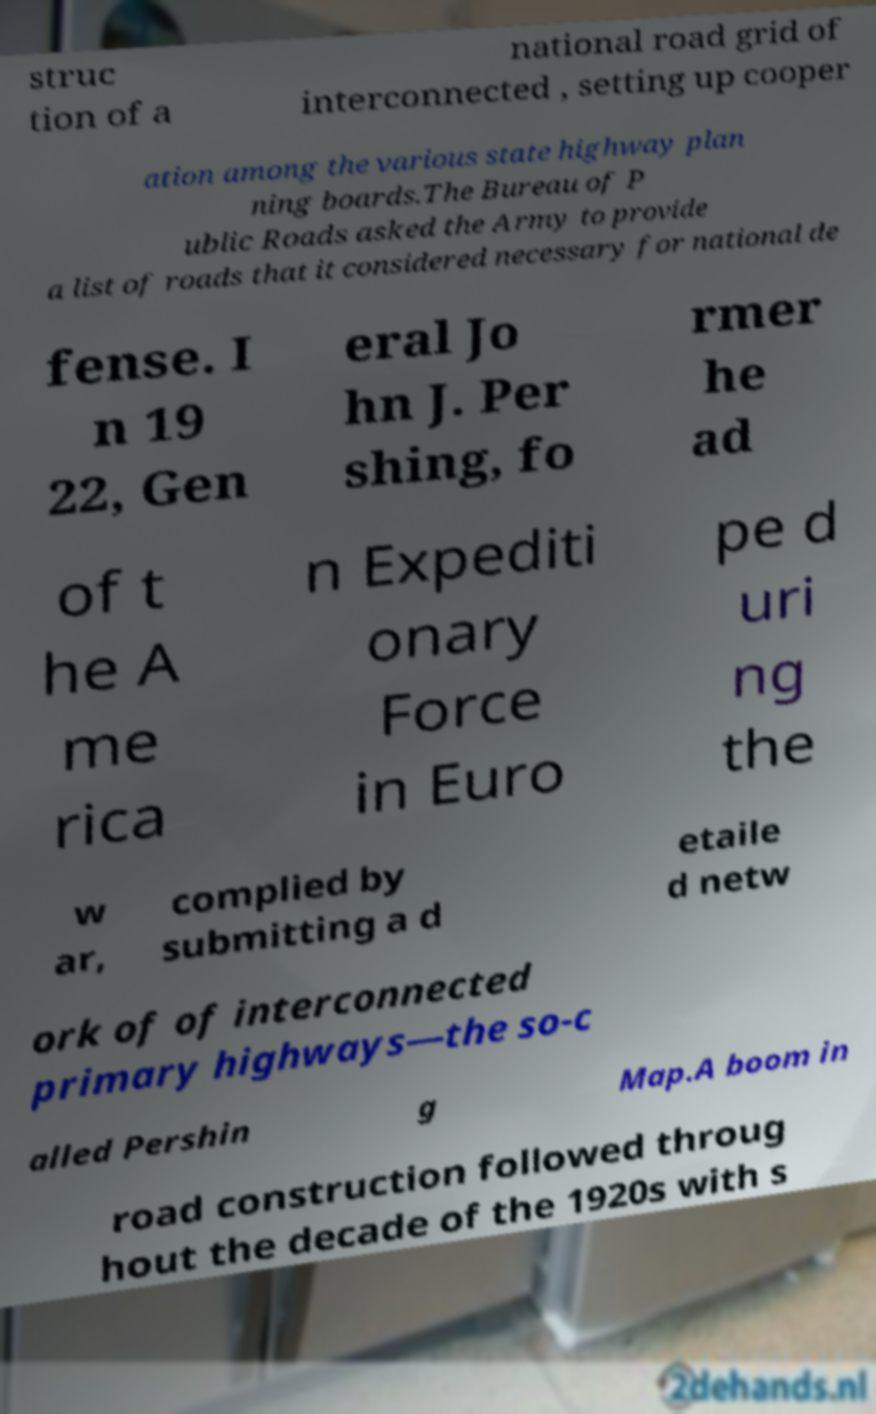Can you read and provide the text displayed in the image?This photo seems to have some interesting text. Can you extract and type it out for me? struc tion of a national road grid of interconnected , setting up cooper ation among the various state highway plan ning boards.The Bureau of P ublic Roads asked the Army to provide a list of roads that it considered necessary for national de fense. I n 19 22, Gen eral Jo hn J. Per shing, fo rmer he ad of t he A me rica n Expediti onary Force in Euro pe d uri ng the w ar, complied by submitting a d etaile d netw ork of of interconnected primary highways—the so-c alled Pershin g Map.A boom in road construction followed throug hout the decade of the 1920s with s 